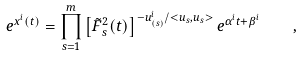<formula> <loc_0><loc_0><loc_500><loc_500>e ^ { x ^ { i } ( t ) } = \prod _ { s = 1 } ^ { m } \left [ \tilde { F } ^ { 2 } _ { s } ( t ) \right ] ^ { - u _ { ( s ) } ^ { i } / < u _ { s } , u _ { s } > } e ^ { \alpha ^ { i } t + \beta ^ { i } } \quad ,</formula> 